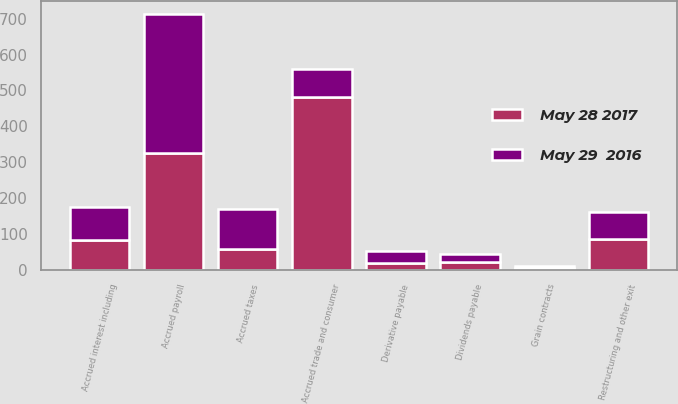Convert chart. <chart><loc_0><loc_0><loc_500><loc_500><stacked_bar_chart><ecel><fcel>Accrued trade and consumer<fcel>Accrued payroll<fcel>Dividends payable<fcel>Accrued taxes<fcel>Accrued interest including<fcel>Grain contracts<fcel>Restructuring and other exit<fcel>Derivative payable<nl><fcel>May 28 2017<fcel>482.6<fcel>326.6<fcel>21.5<fcel>58<fcel>83.8<fcel>5.6<fcel>85<fcel>18.1<nl><fcel>May 29  2016<fcel>76.6<fcel>386.4<fcel>23.8<fcel>110.5<fcel>90.4<fcel>5.5<fcel>76.6<fcel>35.6<nl></chart> 